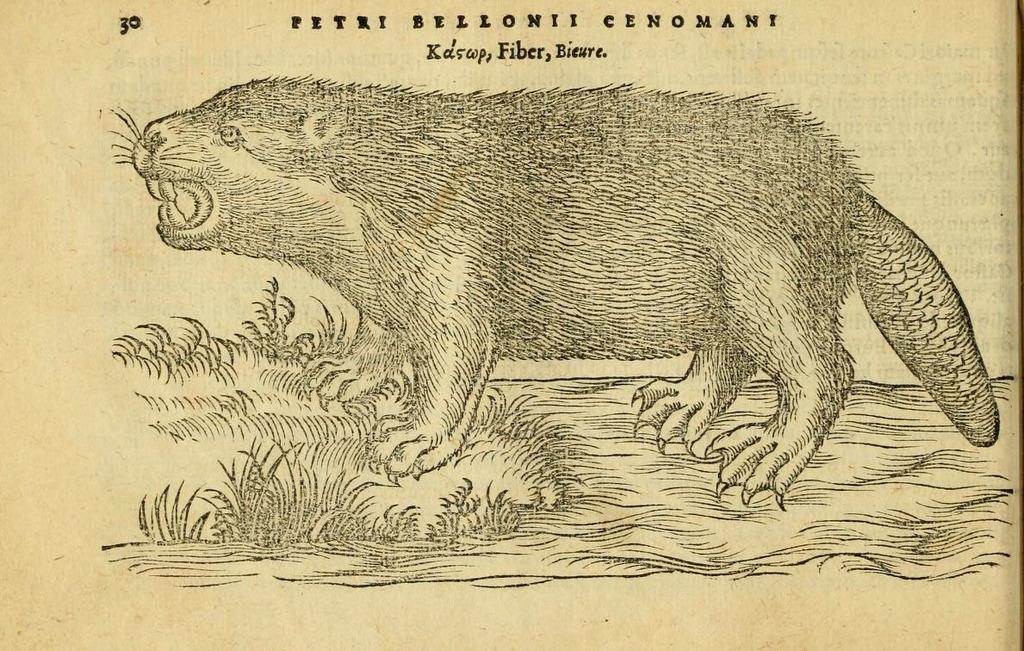What is the main subject of the picture? There is an animal in the picture. What is written at the top of the picture? There is text at the top of the picture. How is the image of the animal presented? The picture appears to be printed. Is there any blood visible in the image? There is no mention of blood in the provided facts, and it is not visible in the image. Can you see a volcano in the background of the image? There is no mention of a volcano in the provided facts, and it is not visible in the image. 